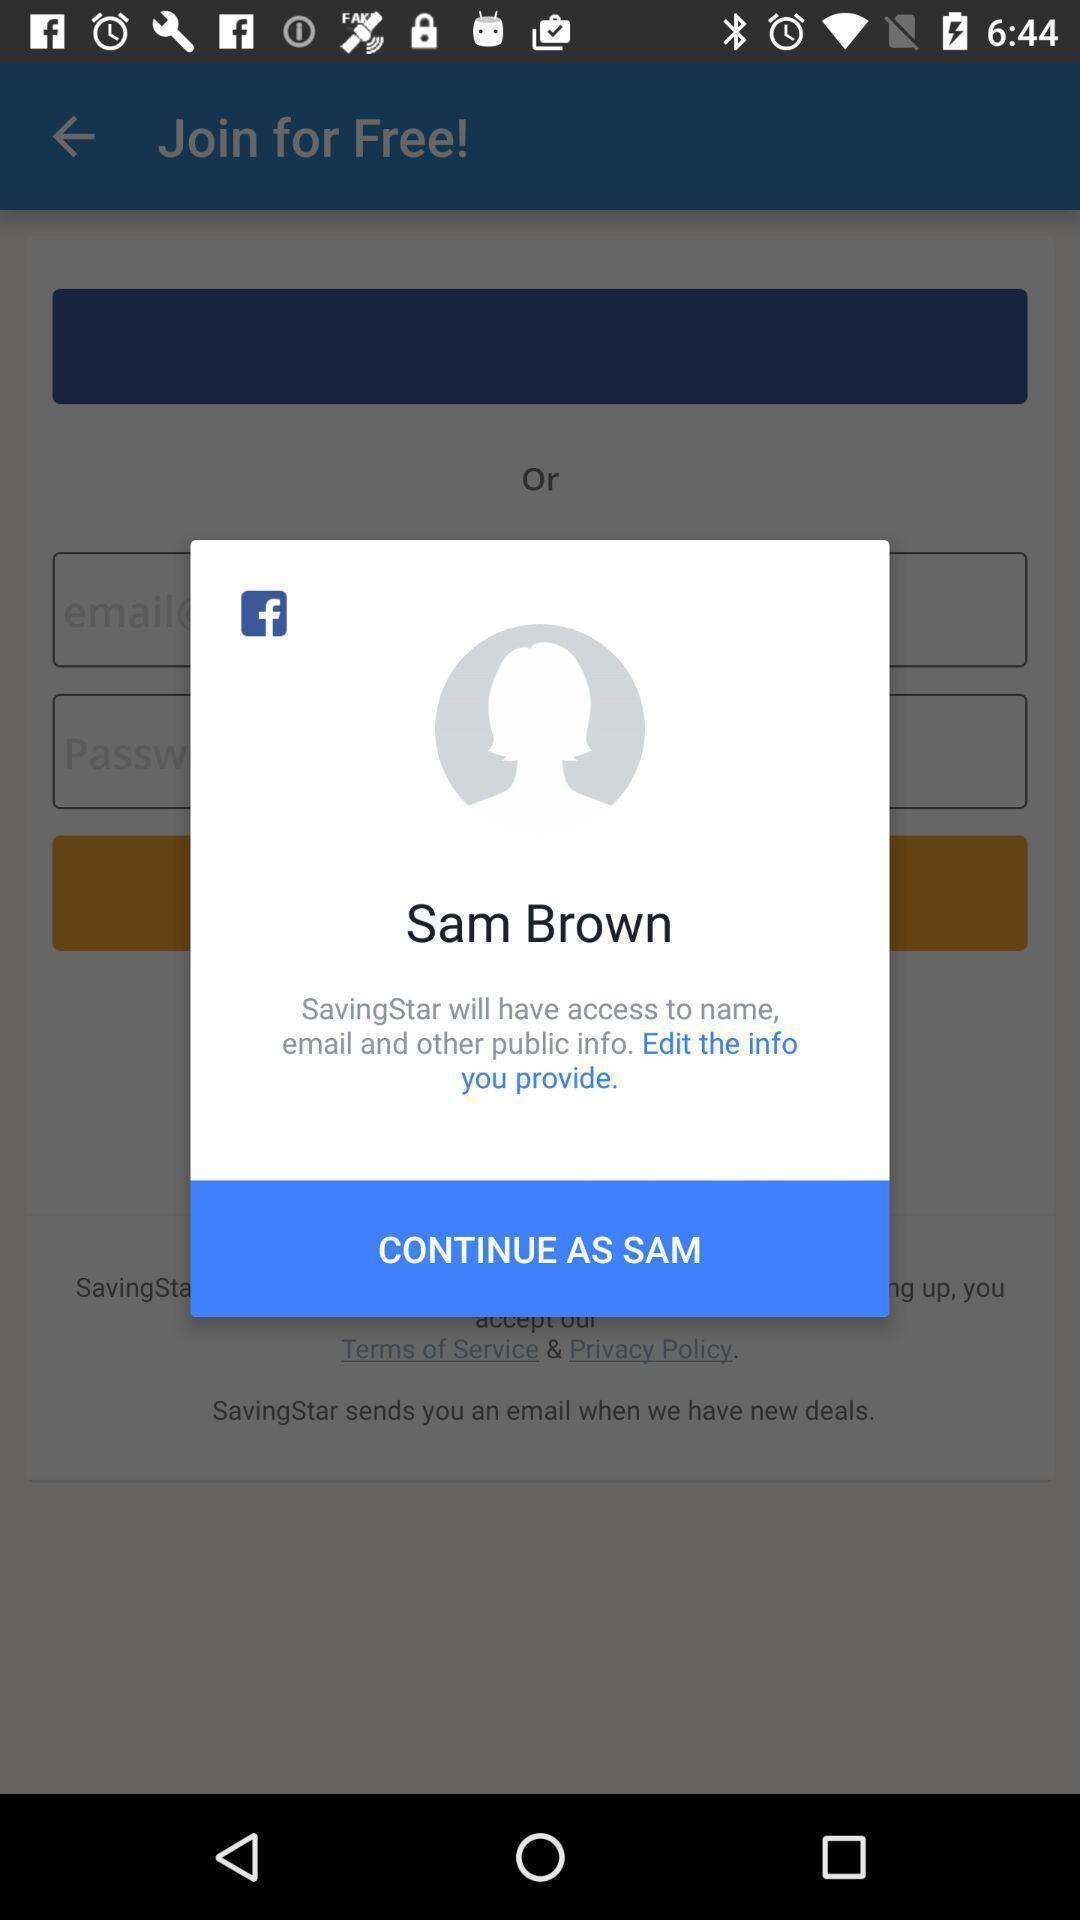Provide a textual representation of this image. Pop-up shows login details to continue with an app. 